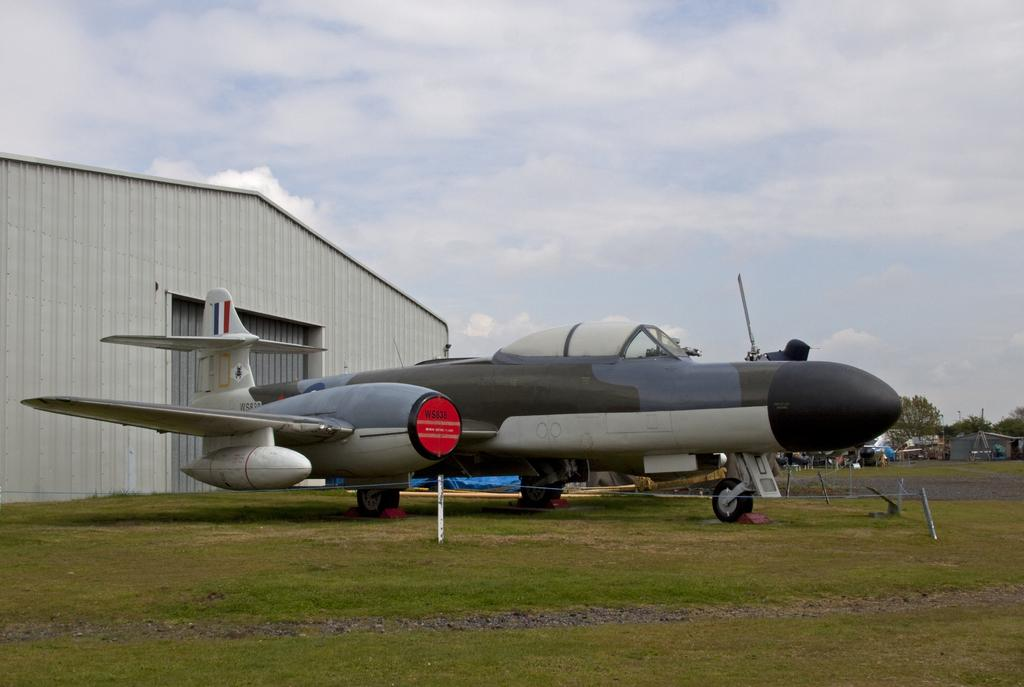What is the main subject in the image? There is an aircraft in the image. What other structures or objects can be seen in the image? There is a shed, trees, fencing, and grass visible in the image. What is the color of the sky in the image? The sky is blue and white in color. How much friction is present between the bat and the grass in the image? There is no bat present in the image, so it is not possible to determine the amount of friction between a bat and the grass. 